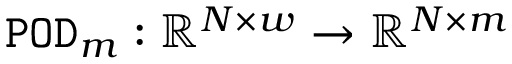<formula> <loc_0><loc_0><loc_500><loc_500>{ \tt P O D } _ { m } \colon \mathbb { R } ^ { N \times w } \rightarrow \mathbb { R } ^ { N \times m }</formula> 